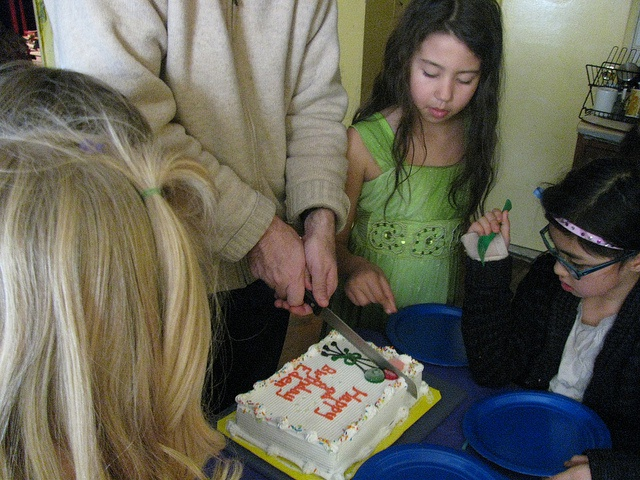Describe the objects in this image and their specific colors. I can see people in black, gray, olive, and darkgray tones, people in black, darkgray, and gray tones, people in black, gray, darkgreen, and green tones, people in black, gray, and darkgray tones, and cake in black, darkgray, gray, and brown tones in this image. 